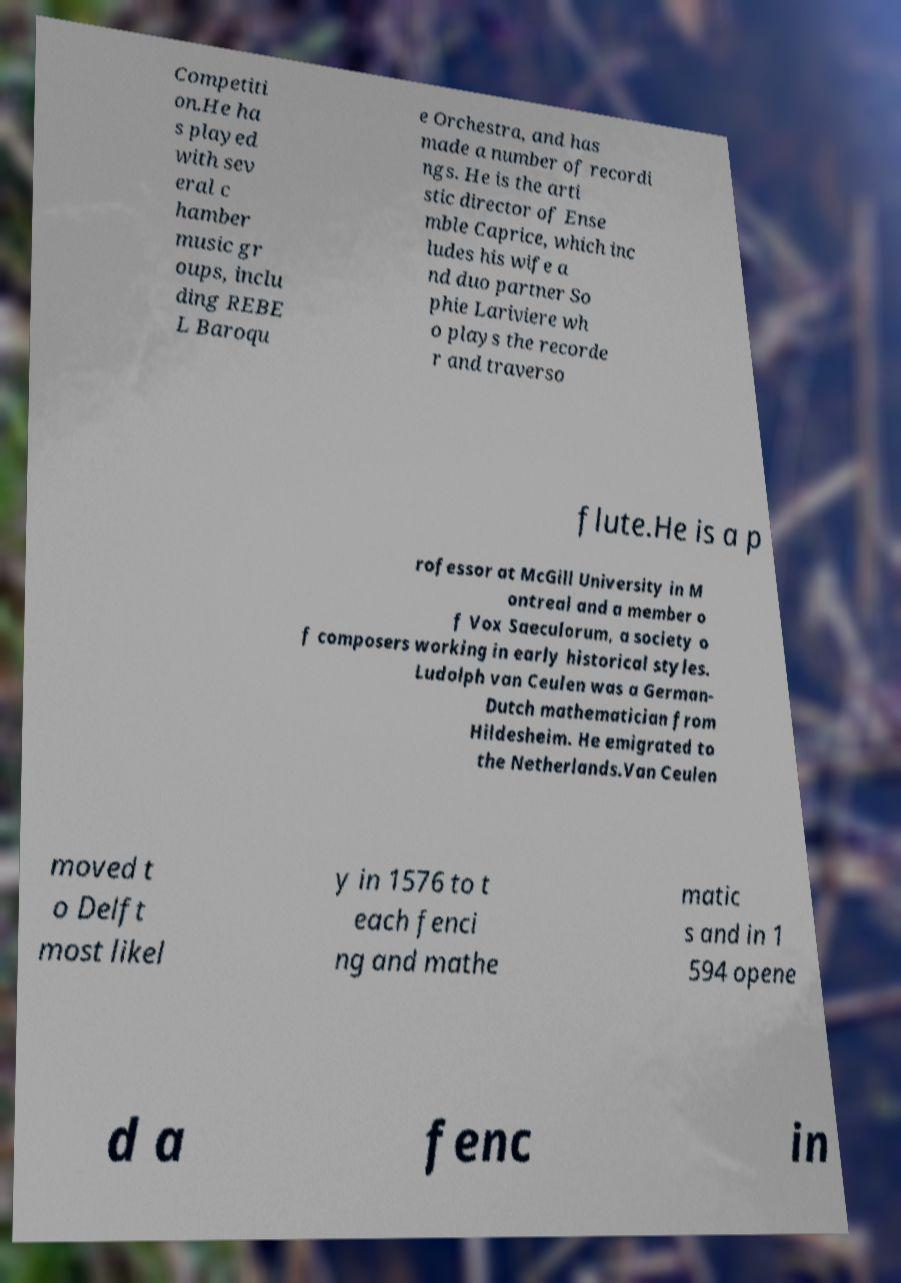Could you assist in decoding the text presented in this image and type it out clearly? Competiti on.He ha s played with sev eral c hamber music gr oups, inclu ding REBE L Baroqu e Orchestra, and has made a number of recordi ngs. He is the arti stic director of Ense mble Caprice, which inc ludes his wife a nd duo partner So phie Lariviere wh o plays the recorde r and traverso flute.He is a p rofessor at McGill University in M ontreal and a member o f Vox Saeculorum, a society o f composers working in early historical styles. Ludolph van Ceulen was a German- Dutch mathematician from Hildesheim. He emigrated to the Netherlands.Van Ceulen moved t o Delft most likel y in 1576 to t each fenci ng and mathe matic s and in 1 594 opene d a fenc in 